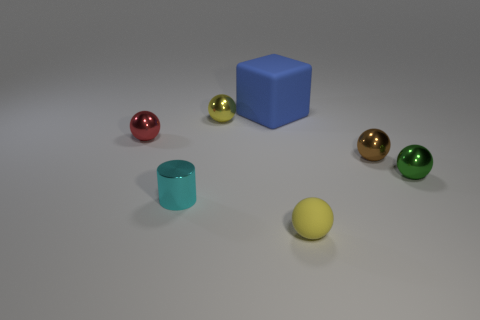Subtract all brown spheres. How many spheres are left? 4 Add 3 brown shiny things. How many objects exist? 10 Subtract all green spheres. How many spheres are left? 4 Subtract all balls. How many objects are left? 2 Subtract all gray blocks. Subtract all cyan cylinders. How many blocks are left? 1 Subtract all yellow cylinders. How many yellow balls are left? 2 Subtract all yellow metal balls. Subtract all yellow metallic objects. How many objects are left? 5 Add 3 small cyan shiny cylinders. How many small cyan shiny cylinders are left? 4 Add 7 red metallic things. How many red metallic things exist? 8 Subtract 0 blue balls. How many objects are left? 7 